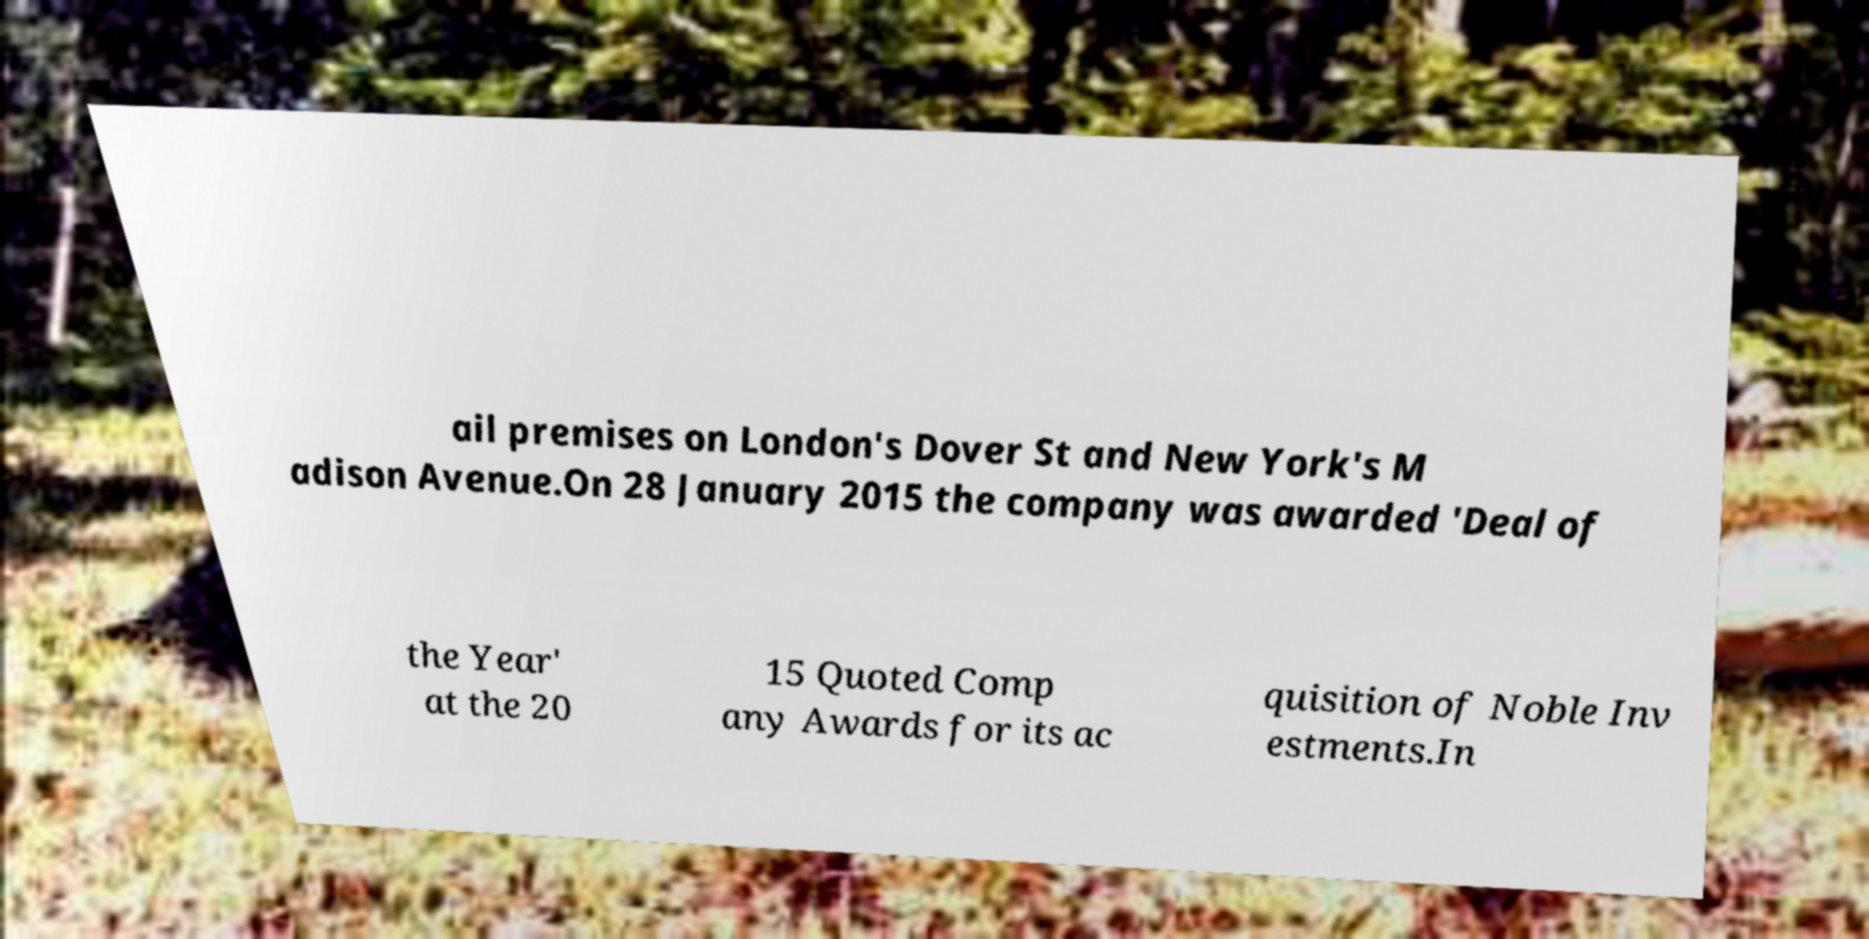Please identify and transcribe the text found in this image. ail premises on London's Dover St and New York's M adison Avenue.On 28 January 2015 the company was awarded 'Deal of the Year' at the 20 15 Quoted Comp any Awards for its ac quisition of Noble Inv estments.In 